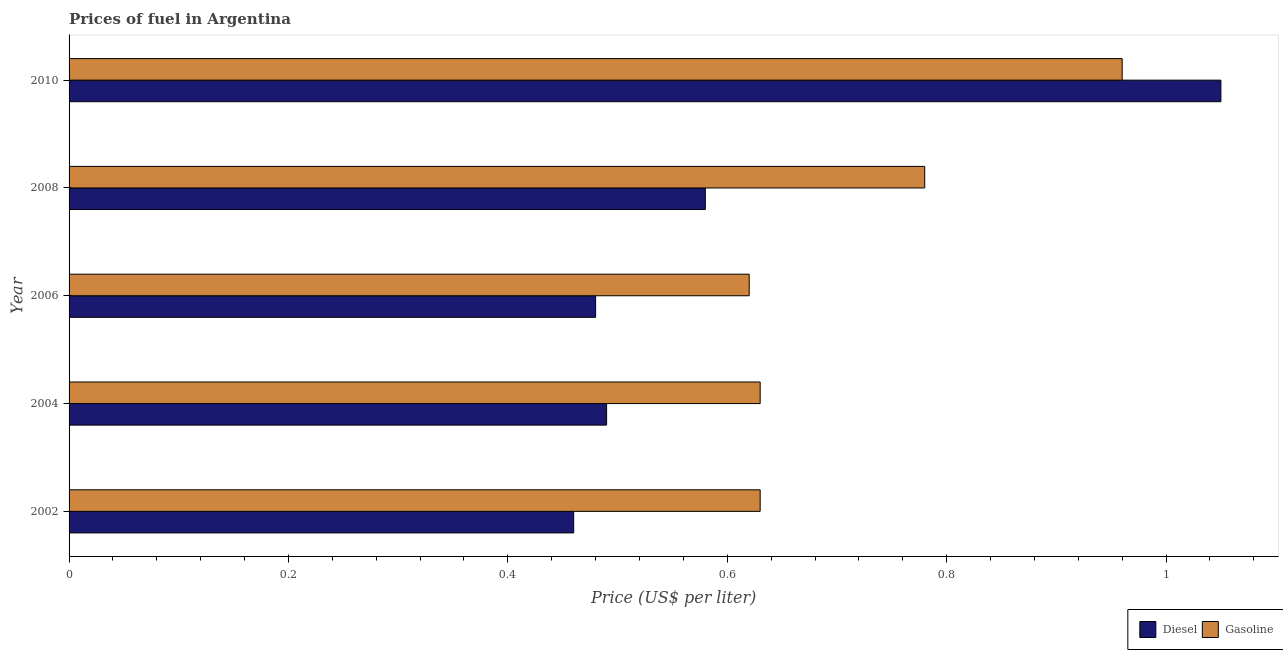How many groups of bars are there?
Provide a succinct answer. 5. How many bars are there on the 2nd tick from the top?
Provide a short and direct response. 2. In how many cases, is the number of bars for a given year not equal to the number of legend labels?
Give a very brief answer. 0. What is the gasoline price in 2002?
Ensure brevity in your answer.  0.63. Across all years, what is the minimum gasoline price?
Your answer should be compact. 0.62. In which year was the diesel price maximum?
Your response must be concise. 2010. In which year was the gasoline price minimum?
Ensure brevity in your answer.  2006. What is the total diesel price in the graph?
Provide a short and direct response. 3.06. What is the difference between the gasoline price in 2006 and that in 2010?
Provide a short and direct response. -0.34. What is the difference between the diesel price in 2008 and the gasoline price in 2004?
Make the answer very short. -0.05. What is the average diesel price per year?
Offer a terse response. 0.61. In the year 2006, what is the difference between the gasoline price and diesel price?
Your response must be concise. 0.14. In how many years, is the gasoline price greater than 1 US$ per litre?
Offer a very short reply. 0. What is the ratio of the gasoline price in 2006 to that in 2010?
Offer a very short reply. 0.65. Is the diesel price in 2002 less than that in 2006?
Give a very brief answer. Yes. Is the difference between the diesel price in 2004 and 2008 greater than the difference between the gasoline price in 2004 and 2008?
Your answer should be compact. Yes. What is the difference between the highest and the second highest diesel price?
Your answer should be very brief. 0.47. What is the difference between the highest and the lowest diesel price?
Give a very brief answer. 0.59. What does the 1st bar from the top in 2010 represents?
Your answer should be very brief. Gasoline. What does the 2nd bar from the bottom in 2002 represents?
Provide a succinct answer. Gasoline. How many years are there in the graph?
Your answer should be compact. 5. Where does the legend appear in the graph?
Ensure brevity in your answer.  Bottom right. What is the title of the graph?
Your answer should be very brief. Prices of fuel in Argentina. What is the label or title of the X-axis?
Keep it short and to the point. Price (US$ per liter). What is the label or title of the Y-axis?
Offer a very short reply. Year. What is the Price (US$ per liter) of Diesel in 2002?
Your response must be concise. 0.46. What is the Price (US$ per liter) in Gasoline in 2002?
Your response must be concise. 0.63. What is the Price (US$ per liter) in Diesel in 2004?
Make the answer very short. 0.49. What is the Price (US$ per liter) of Gasoline in 2004?
Provide a succinct answer. 0.63. What is the Price (US$ per liter) of Diesel in 2006?
Give a very brief answer. 0.48. What is the Price (US$ per liter) of Gasoline in 2006?
Keep it short and to the point. 0.62. What is the Price (US$ per liter) in Diesel in 2008?
Provide a succinct answer. 0.58. What is the Price (US$ per liter) in Gasoline in 2008?
Keep it short and to the point. 0.78. What is the Price (US$ per liter) of Diesel in 2010?
Give a very brief answer. 1.05. Across all years, what is the minimum Price (US$ per liter) in Diesel?
Provide a short and direct response. 0.46. Across all years, what is the minimum Price (US$ per liter) of Gasoline?
Offer a very short reply. 0.62. What is the total Price (US$ per liter) in Diesel in the graph?
Make the answer very short. 3.06. What is the total Price (US$ per liter) of Gasoline in the graph?
Make the answer very short. 3.62. What is the difference between the Price (US$ per liter) in Diesel in 2002 and that in 2004?
Make the answer very short. -0.03. What is the difference between the Price (US$ per liter) of Gasoline in 2002 and that in 2004?
Your answer should be very brief. 0. What is the difference between the Price (US$ per liter) in Diesel in 2002 and that in 2006?
Your response must be concise. -0.02. What is the difference between the Price (US$ per liter) of Diesel in 2002 and that in 2008?
Your response must be concise. -0.12. What is the difference between the Price (US$ per liter) in Diesel in 2002 and that in 2010?
Offer a very short reply. -0.59. What is the difference between the Price (US$ per liter) in Gasoline in 2002 and that in 2010?
Offer a very short reply. -0.33. What is the difference between the Price (US$ per liter) of Gasoline in 2004 and that in 2006?
Provide a succinct answer. 0.01. What is the difference between the Price (US$ per liter) of Diesel in 2004 and that in 2008?
Give a very brief answer. -0.09. What is the difference between the Price (US$ per liter) in Gasoline in 2004 and that in 2008?
Provide a succinct answer. -0.15. What is the difference between the Price (US$ per liter) in Diesel in 2004 and that in 2010?
Your answer should be compact. -0.56. What is the difference between the Price (US$ per liter) in Gasoline in 2004 and that in 2010?
Provide a short and direct response. -0.33. What is the difference between the Price (US$ per liter) in Diesel in 2006 and that in 2008?
Your answer should be compact. -0.1. What is the difference between the Price (US$ per liter) in Gasoline in 2006 and that in 2008?
Provide a succinct answer. -0.16. What is the difference between the Price (US$ per liter) of Diesel in 2006 and that in 2010?
Make the answer very short. -0.57. What is the difference between the Price (US$ per liter) of Gasoline in 2006 and that in 2010?
Provide a succinct answer. -0.34. What is the difference between the Price (US$ per liter) of Diesel in 2008 and that in 2010?
Provide a short and direct response. -0.47. What is the difference between the Price (US$ per liter) in Gasoline in 2008 and that in 2010?
Offer a very short reply. -0.18. What is the difference between the Price (US$ per liter) of Diesel in 2002 and the Price (US$ per liter) of Gasoline in 2004?
Offer a very short reply. -0.17. What is the difference between the Price (US$ per liter) in Diesel in 2002 and the Price (US$ per liter) in Gasoline in 2006?
Make the answer very short. -0.16. What is the difference between the Price (US$ per liter) of Diesel in 2002 and the Price (US$ per liter) of Gasoline in 2008?
Give a very brief answer. -0.32. What is the difference between the Price (US$ per liter) of Diesel in 2002 and the Price (US$ per liter) of Gasoline in 2010?
Provide a succinct answer. -0.5. What is the difference between the Price (US$ per liter) of Diesel in 2004 and the Price (US$ per liter) of Gasoline in 2006?
Ensure brevity in your answer.  -0.13. What is the difference between the Price (US$ per liter) in Diesel in 2004 and the Price (US$ per liter) in Gasoline in 2008?
Give a very brief answer. -0.29. What is the difference between the Price (US$ per liter) of Diesel in 2004 and the Price (US$ per liter) of Gasoline in 2010?
Offer a very short reply. -0.47. What is the difference between the Price (US$ per liter) of Diesel in 2006 and the Price (US$ per liter) of Gasoline in 2010?
Your answer should be compact. -0.48. What is the difference between the Price (US$ per liter) in Diesel in 2008 and the Price (US$ per liter) in Gasoline in 2010?
Provide a short and direct response. -0.38. What is the average Price (US$ per liter) in Diesel per year?
Give a very brief answer. 0.61. What is the average Price (US$ per liter) of Gasoline per year?
Provide a succinct answer. 0.72. In the year 2002, what is the difference between the Price (US$ per liter) in Diesel and Price (US$ per liter) in Gasoline?
Offer a very short reply. -0.17. In the year 2004, what is the difference between the Price (US$ per liter) in Diesel and Price (US$ per liter) in Gasoline?
Your response must be concise. -0.14. In the year 2006, what is the difference between the Price (US$ per liter) in Diesel and Price (US$ per liter) in Gasoline?
Offer a terse response. -0.14. In the year 2010, what is the difference between the Price (US$ per liter) of Diesel and Price (US$ per liter) of Gasoline?
Provide a short and direct response. 0.09. What is the ratio of the Price (US$ per liter) of Diesel in 2002 to that in 2004?
Provide a succinct answer. 0.94. What is the ratio of the Price (US$ per liter) of Gasoline in 2002 to that in 2006?
Keep it short and to the point. 1.02. What is the ratio of the Price (US$ per liter) in Diesel in 2002 to that in 2008?
Your answer should be compact. 0.79. What is the ratio of the Price (US$ per liter) in Gasoline in 2002 to that in 2008?
Your response must be concise. 0.81. What is the ratio of the Price (US$ per liter) in Diesel in 2002 to that in 2010?
Keep it short and to the point. 0.44. What is the ratio of the Price (US$ per liter) in Gasoline in 2002 to that in 2010?
Provide a succinct answer. 0.66. What is the ratio of the Price (US$ per liter) in Diesel in 2004 to that in 2006?
Offer a very short reply. 1.02. What is the ratio of the Price (US$ per liter) in Gasoline in 2004 to that in 2006?
Provide a short and direct response. 1.02. What is the ratio of the Price (US$ per liter) of Diesel in 2004 to that in 2008?
Provide a short and direct response. 0.84. What is the ratio of the Price (US$ per liter) in Gasoline in 2004 to that in 2008?
Keep it short and to the point. 0.81. What is the ratio of the Price (US$ per liter) in Diesel in 2004 to that in 2010?
Make the answer very short. 0.47. What is the ratio of the Price (US$ per liter) in Gasoline in 2004 to that in 2010?
Give a very brief answer. 0.66. What is the ratio of the Price (US$ per liter) of Diesel in 2006 to that in 2008?
Keep it short and to the point. 0.83. What is the ratio of the Price (US$ per liter) of Gasoline in 2006 to that in 2008?
Your response must be concise. 0.79. What is the ratio of the Price (US$ per liter) of Diesel in 2006 to that in 2010?
Ensure brevity in your answer.  0.46. What is the ratio of the Price (US$ per liter) in Gasoline in 2006 to that in 2010?
Your answer should be very brief. 0.65. What is the ratio of the Price (US$ per liter) of Diesel in 2008 to that in 2010?
Keep it short and to the point. 0.55. What is the ratio of the Price (US$ per liter) in Gasoline in 2008 to that in 2010?
Keep it short and to the point. 0.81. What is the difference between the highest and the second highest Price (US$ per liter) of Diesel?
Offer a very short reply. 0.47. What is the difference between the highest and the second highest Price (US$ per liter) of Gasoline?
Ensure brevity in your answer.  0.18. What is the difference between the highest and the lowest Price (US$ per liter) in Diesel?
Ensure brevity in your answer.  0.59. What is the difference between the highest and the lowest Price (US$ per liter) of Gasoline?
Your response must be concise. 0.34. 